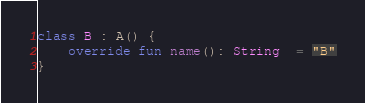Convert code to text. <code><loc_0><loc_0><loc_500><loc_500><_Kotlin_>class B : A() {
    override fun name(): String  = "B"
}
</code> 